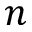<formula> <loc_0><loc_0><loc_500><loc_500>n</formula> 